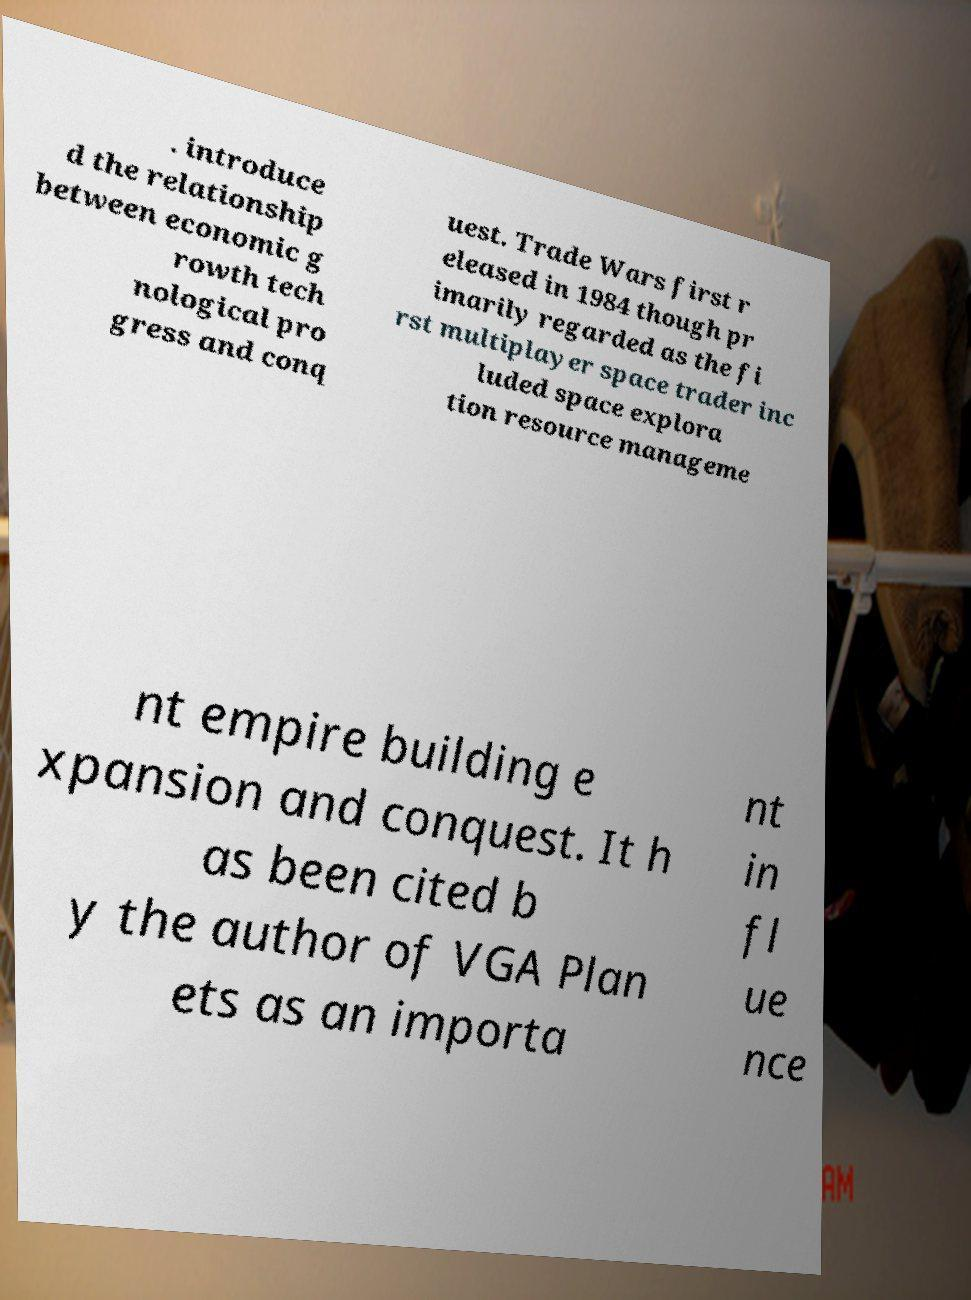Please identify and transcribe the text found in this image. . introduce d the relationship between economic g rowth tech nological pro gress and conq uest. Trade Wars first r eleased in 1984 though pr imarily regarded as the fi rst multiplayer space trader inc luded space explora tion resource manageme nt empire building e xpansion and conquest. It h as been cited b y the author of VGA Plan ets as an importa nt in fl ue nce 